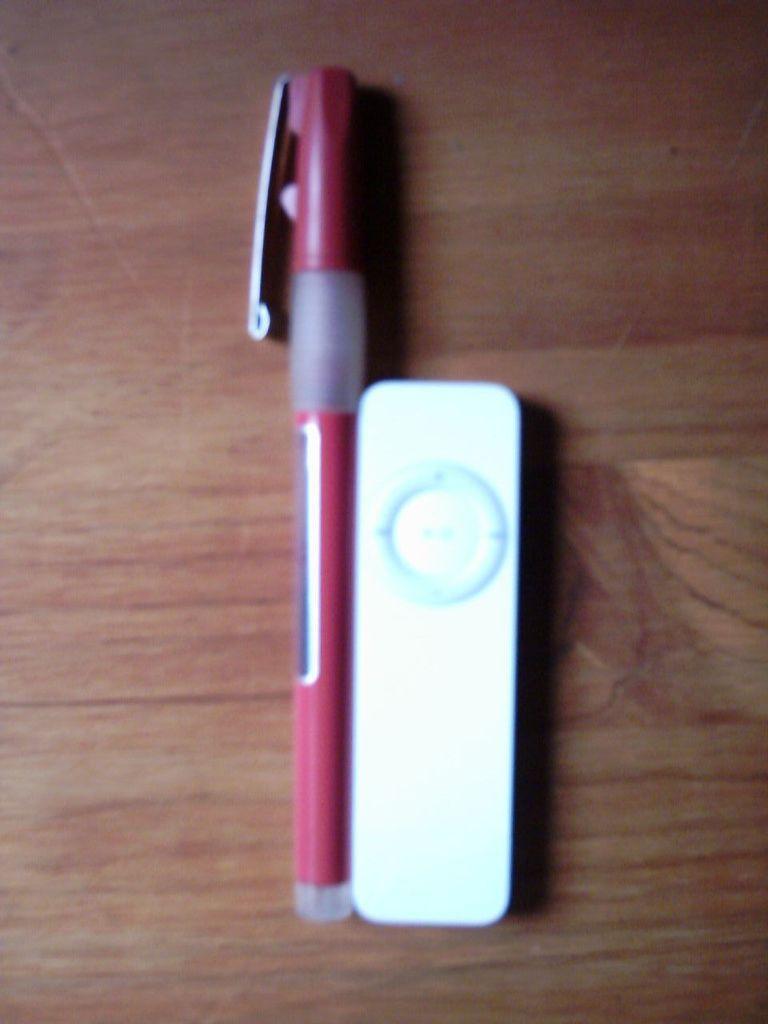Please provide a concise description of this image. This image is taken indoors. At the bottom of the image there is a table with a pen and a remote on it. 